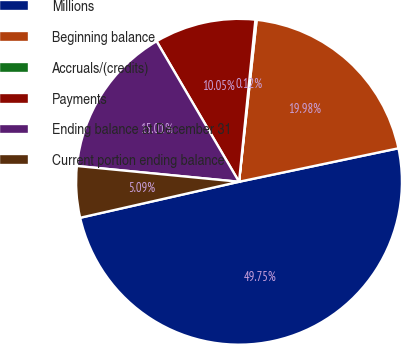Convert chart. <chart><loc_0><loc_0><loc_500><loc_500><pie_chart><fcel>Millions<fcel>Beginning balance<fcel>Accruals/(credits)<fcel>Payments<fcel>Ending balance at December 31<fcel>Current portion ending balance<nl><fcel>49.75%<fcel>19.98%<fcel>0.12%<fcel>10.05%<fcel>15.01%<fcel>5.09%<nl></chart> 